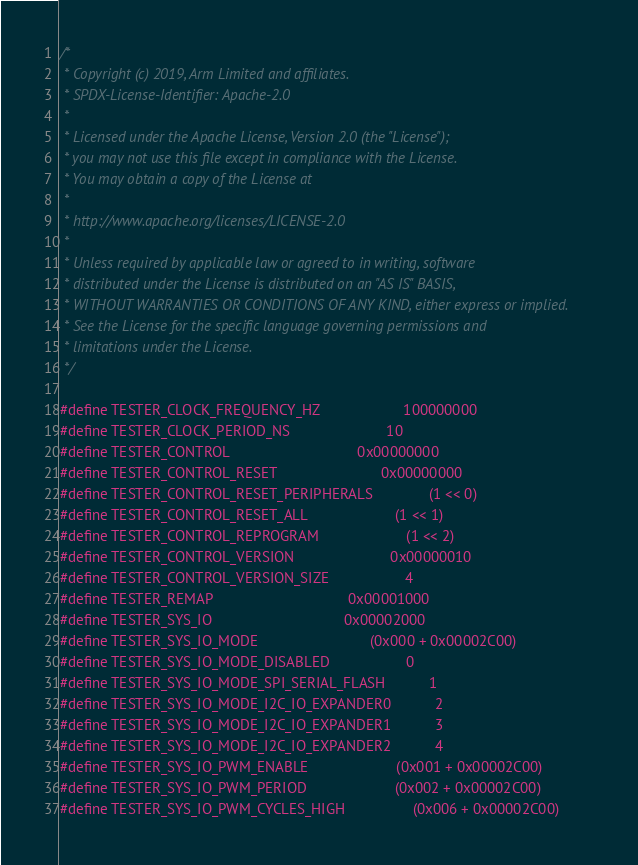Convert code to text. <code><loc_0><loc_0><loc_500><loc_500><_C_>/*
 * Copyright (c) 2019, Arm Limited and affiliates.
 * SPDX-License-Identifier: Apache-2.0
 *
 * Licensed under the Apache License, Version 2.0 (the "License");
 * you may not use this file except in compliance with the License.
 * You may obtain a copy of the License at
 *
 * http://www.apache.org/licenses/LICENSE-2.0
 *
 * Unless required by applicable law or agreed to in writing, software
 * distributed under the License is distributed on an "AS IS" BASIS,
 * WITHOUT WARRANTIES OR CONDITIONS OF ANY KIND, either express or implied.
 * See the License for the specific language governing permissions and
 * limitations under the License.
 */

#define TESTER_CLOCK_FREQUENCY_HZ                     100000000
#define TESTER_CLOCK_PERIOD_NS                        10
#define TESTER_CONTROL                                0x00000000
#define TESTER_CONTROL_RESET                          0x00000000
#define TESTER_CONTROL_RESET_PERIPHERALS              (1 << 0)
#define TESTER_CONTROL_RESET_ALL                      (1 << 1)
#define TESTER_CONTROL_REPROGRAM                      (1 << 2)
#define TESTER_CONTROL_VERSION                        0x00000010
#define TESTER_CONTROL_VERSION_SIZE                   4
#define TESTER_REMAP                                  0x00001000
#define TESTER_SYS_IO                                 0x00002000
#define TESTER_SYS_IO_MODE                            (0x000 + 0x00002C00)
#define TESTER_SYS_IO_MODE_DISABLED                   0
#define TESTER_SYS_IO_MODE_SPI_SERIAL_FLASH           1
#define TESTER_SYS_IO_MODE_I2C_IO_EXPANDER0           2
#define TESTER_SYS_IO_MODE_I2C_IO_EXPANDER1           3
#define TESTER_SYS_IO_MODE_I2C_IO_EXPANDER2           4
#define TESTER_SYS_IO_PWM_ENABLE                      (0x001 + 0x00002C00)
#define TESTER_SYS_IO_PWM_PERIOD                      (0x002 + 0x00002C00)
#define TESTER_SYS_IO_PWM_CYCLES_HIGH                 (0x006 + 0x00002C00)</code> 